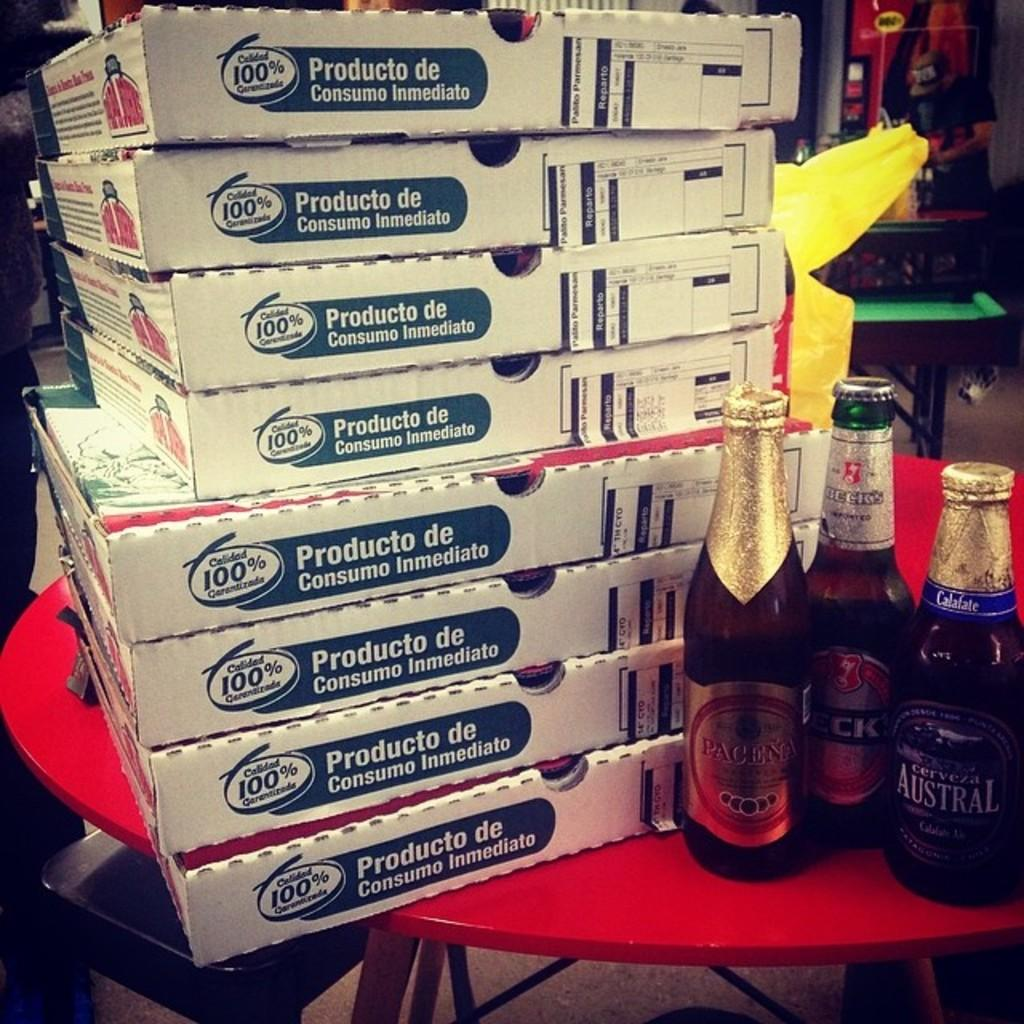What is the main object in the image? There is a table in the image. What items are placed on the table? There are boxes and bottles on the table. Can you describe anything in the background of the image? There is a person wearing a cap and a plastic cover in the background. What type of wilderness can be seen in the background of the image? There is no wilderness present in the image; it features a table with boxes and bottles, and a person wearing a cap in the background. 